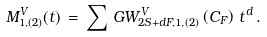<formula> <loc_0><loc_0><loc_500><loc_500>M ^ { V } _ { 1 , ( 2 ) } ( t ) \, = \, \sum \, G W _ { 2 S + d F , 1 , ( 2 ) } ^ { V } \left ( C _ { F } \right ) \, t ^ { d } \, .</formula> 